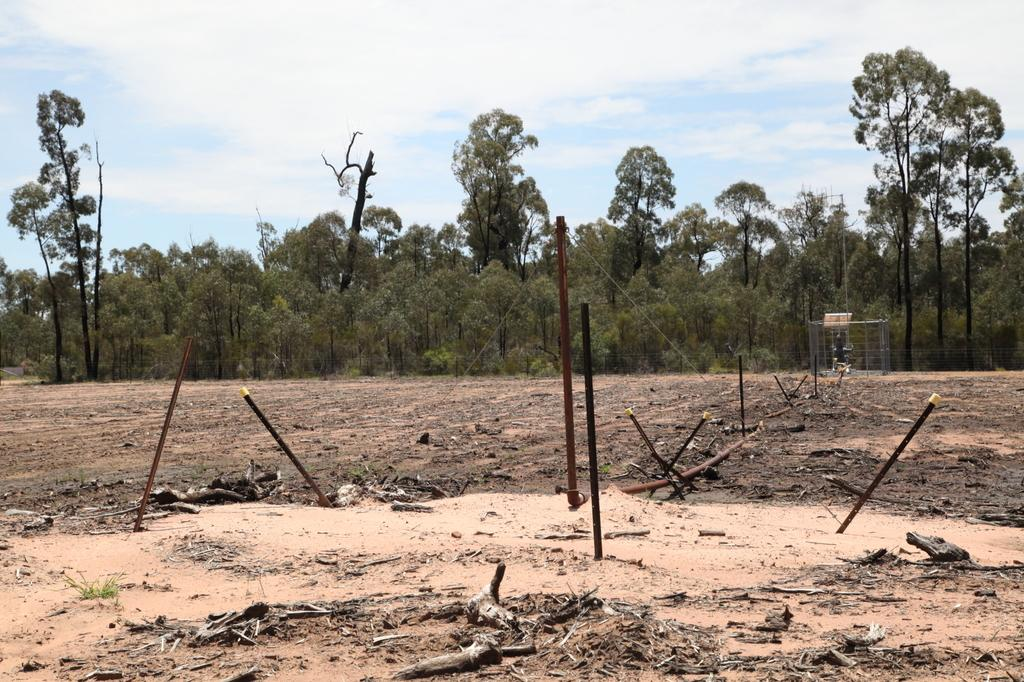Where was the image taken? The image was clicked outside. What can be seen in the foreground of the image? There are metal rods and a metal object in the foreground of the image. What is visible on the ground in the image? The ground is visible in the image. What is visible in the background of the image? There is a sky and trees in the background of the image. What type of cheese is being blown away by the wind in the image? There is no cheese or wind present in the image. Is there an umbrella visible in the image? No, there is no umbrella present in the image. 